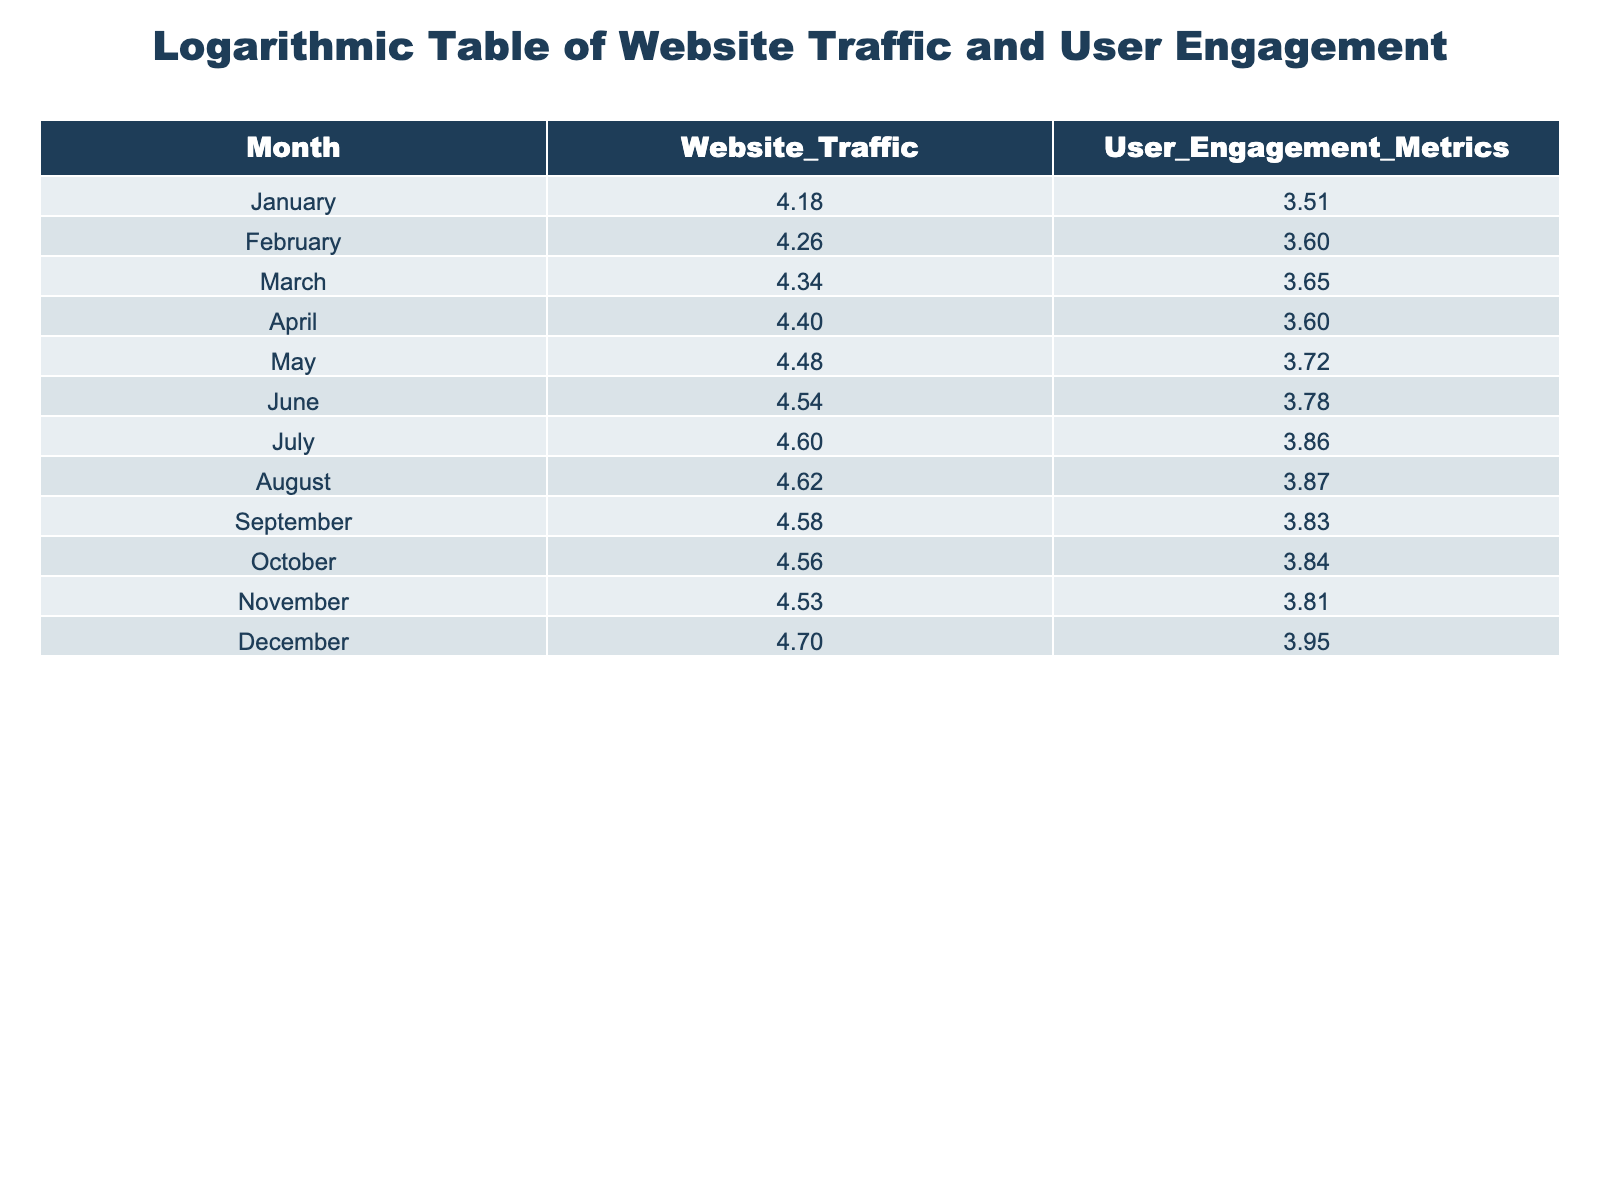What was the website traffic in December? The table directly shows the value for website traffic in December, which is recorded as 50000.
Answer: 50000 Which month had the highest user engagement metrics? By looking at the user engagement metrics column, December shows the highest value of 9000, which is higher than any other month.
Answer: December What is the difference in website traffic between March and April? The website traffic for March is 22000, and for April, it is 25000. The difference is calculated as 25000 - 22000 = 3000.
Answer: 3000 What is the average value of user engagement metrics from January to June? To calculate the average, we sum the user engagement metrics for each month from January (3200) to June (6000): 3200 + 4000 + 4500 + 4000 + 5200 + 6000 = 31900. We have 6 months, so the average is 31900 / 6 = 5316.67, which rounds to 5317.
Answer: 5317 Did the website traffic increase from May to June? The value for website traffic in May is 30000, and in June, it is 35000. Since 35000 is greater than 30000, this confirms that there was an increase.
Answer: Yes What was the total website traffic from January to October? The total website traffic is found by summing the values for January (15000) through October (36000): 15000 + 18000 + 22000 + 25000 + 30000 + 35000 + 40000 + 42000 + 38000 + 36000 = 286000.
Answer: 286000 Which month has the lowest user engagement metrics? By examining the user engagement metrics, January has the lowest recorded value of 3200 compared to other months.
Answer: January What was the percentage increase in user engagement metrics from August to December? First, find the user engagement metrics for August (7400) and December (9000). The increase is calculated as 9000 - 7400 = 1600. To find the percentage increase: (1600 / 7400) * 100 ≈ 21.62%.
Answer: Approximately 21.62% Which two months had the closest website traffic values? Comparing the website traffic values, October (36000) and November (34000) are the closest, with a difference of 2000 between them.
Answer: October and November 